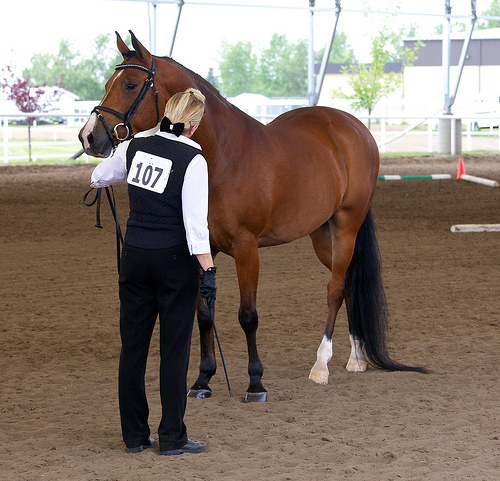<image>
Can you confirm if the horse is above the dirt? No. The horse is not positioned above the dirt. The vertical arrangement shows a different relationship. Is there a horse above the man? No. The horse is not positioned above the man. The vertical arrangement shows a different relationship. 